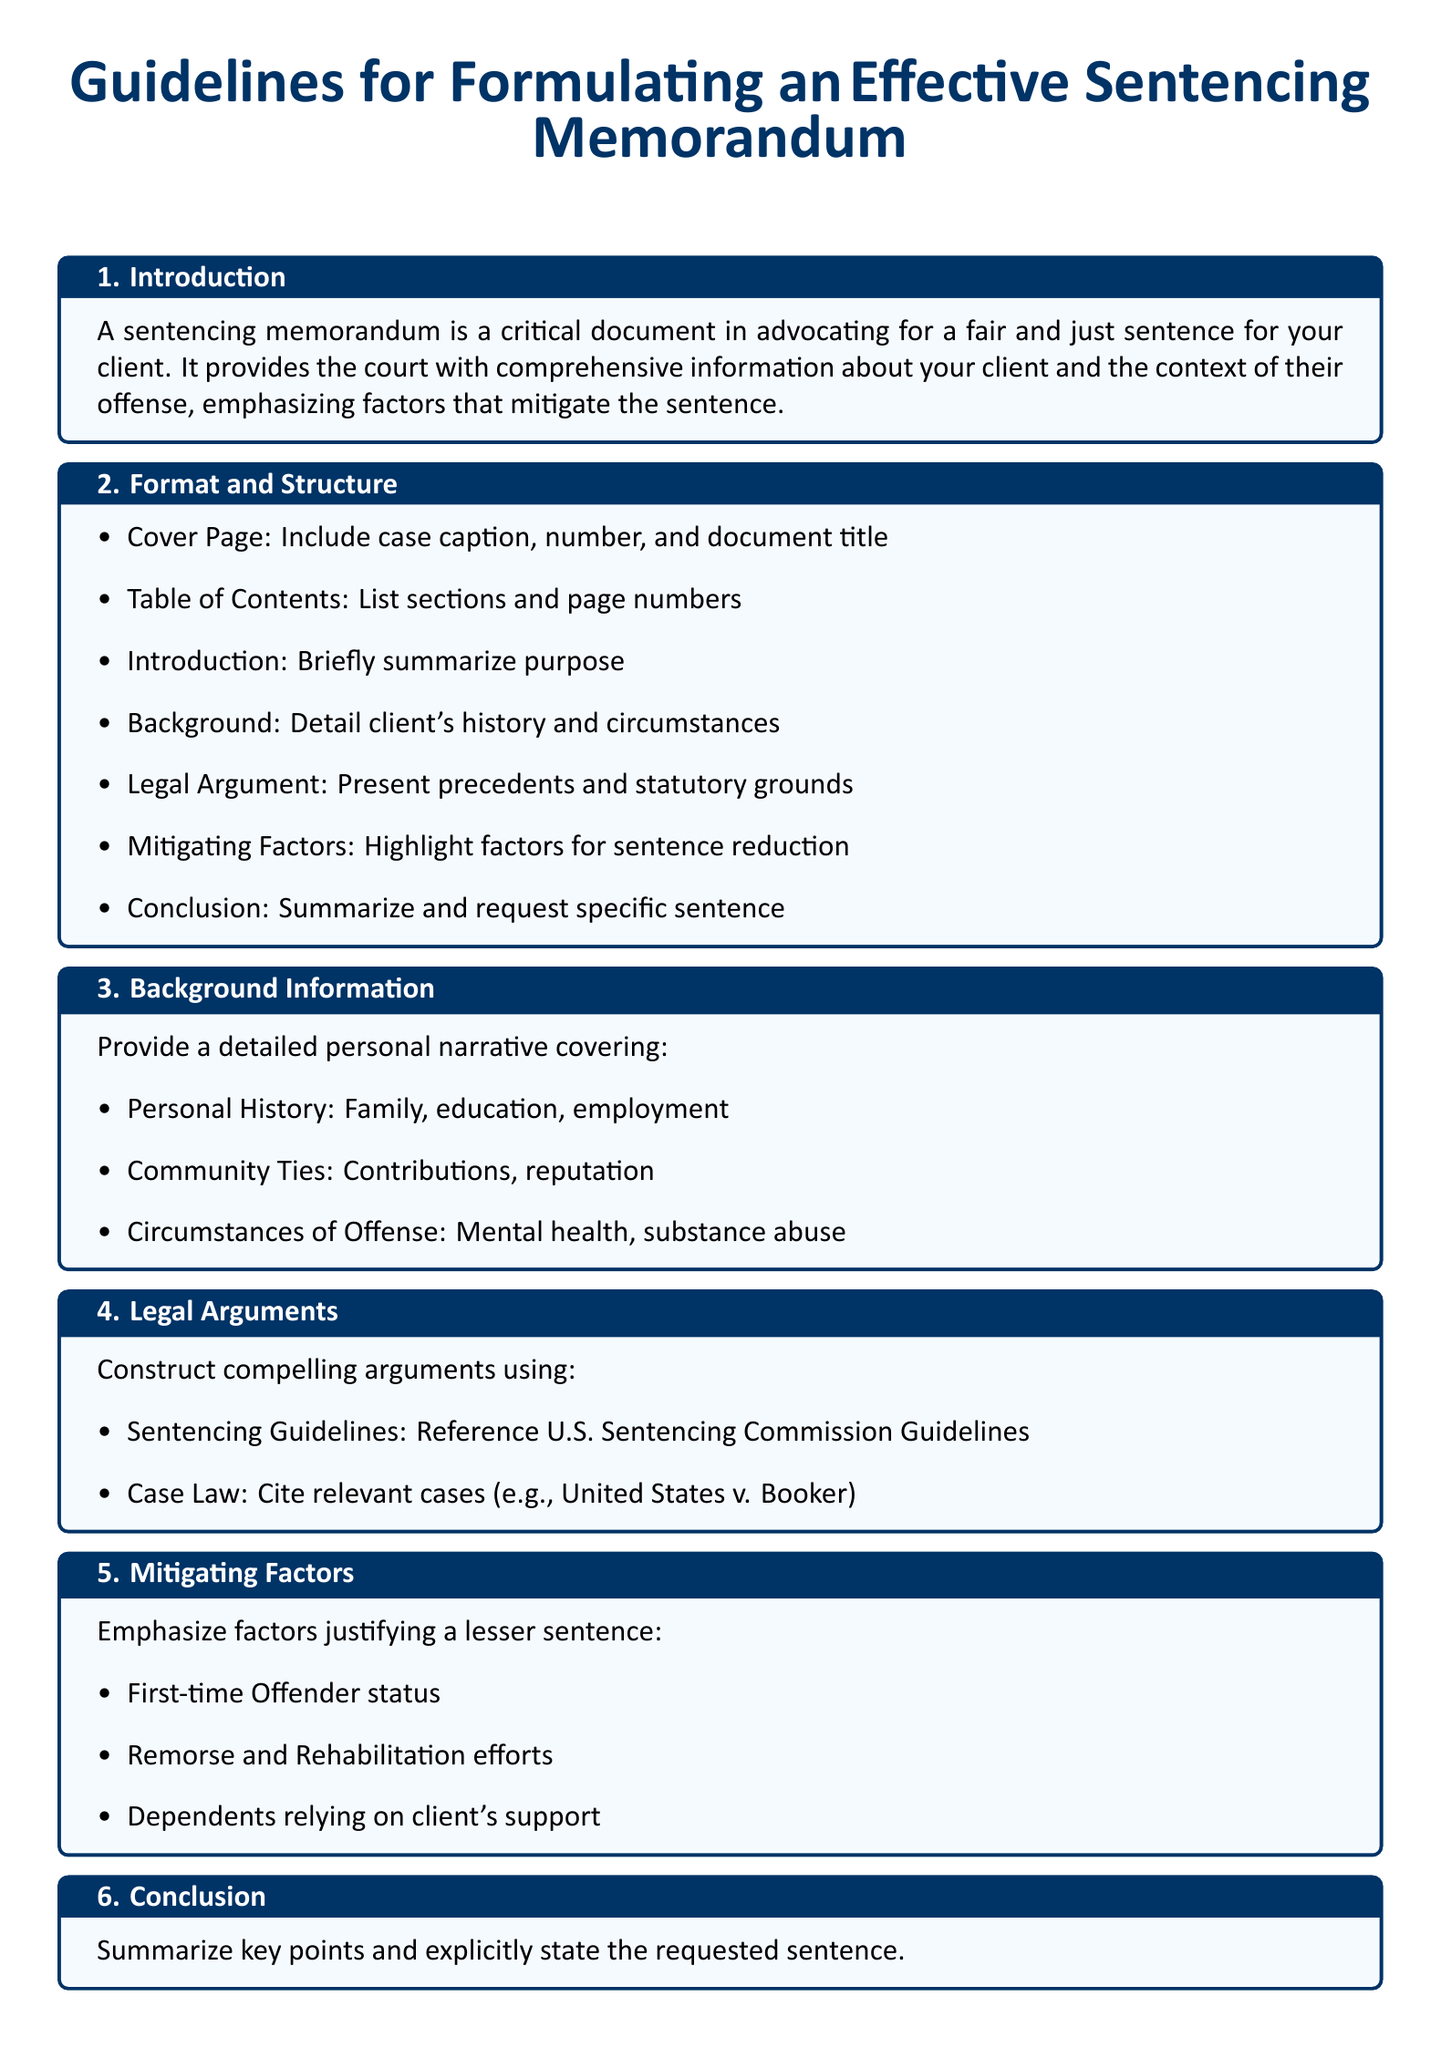What is the title of the document? The title is prominently displayed at the beginning of the document.
Answer: Guidelines for Formulating an Effective Sentencing Memorandum How many main sections are in the document? The document lists distinct sections following the introduction.
Answer: 7 What should be included in the Cover Page? The document specifies essential elements to present on the Cover Page.
Answer: Case caption, number, and document title What is a key element to include in the legal arguments? The text outlines important components to support the legal case.
Answer: U.S. Sentencing Commission Guidelines Name one mitigating factor emphasized in the document. The document lists factors that justify a reduced sentence.
Answer: First-time Offender status What type of tone should be maintained in the memorandum? The document provides advice on the appropriate style for writing the memorandum.
Answer: Professional Tone What is the main purpose of a sentencing memorandum? The introduction clarifies the fundamental objective of the document.
Answer: Advocate for a fair and just sentence What does the document suggest for supporting the arguments? The document advises on evidence that can strengthen the case.
Answer: Provide Supporting Documentation 